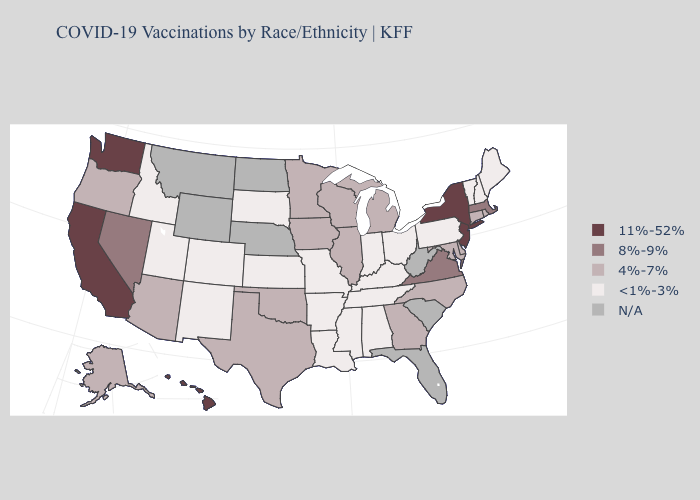Which states have the lowest value in the MidWest?
Be succinct. Indiana, Kansas, Missouri, Ohio, South Dakota. Does the first symbol in the legend represent the smallest category?
Concise answer only. No. What is the value of Arizona?
Concise answer only. 4%-7%. What is the highest value in states that border New Mexico?
Write a very short answer. 4%-7%. Does Hawaii have the highest value in the USA?
Be succinct. Yes. What is the value of Louisiana?
Be succinct. <1%-3%. What is the highest value in the USA?
Concise answer only. 11%-52%. What is the value of Delaware?
Quick response, please. 4%-7%. Does the first symbol in the legend represent the smallest category?
Give a very brief answer. No. Among the states that border Texas , which have the lowest value?
Concise answer only. Arkansas, Louisiana, New Mexico. What is the value of Texas?
Quick response, please. 4%-7%. What is the value of Colorado?
Write a very short answer. <1%-3%. Is the legend a continuous bar?
Concise answer only. No. What is the value of Minnesota?
Keep it brief. 4%-7%. 